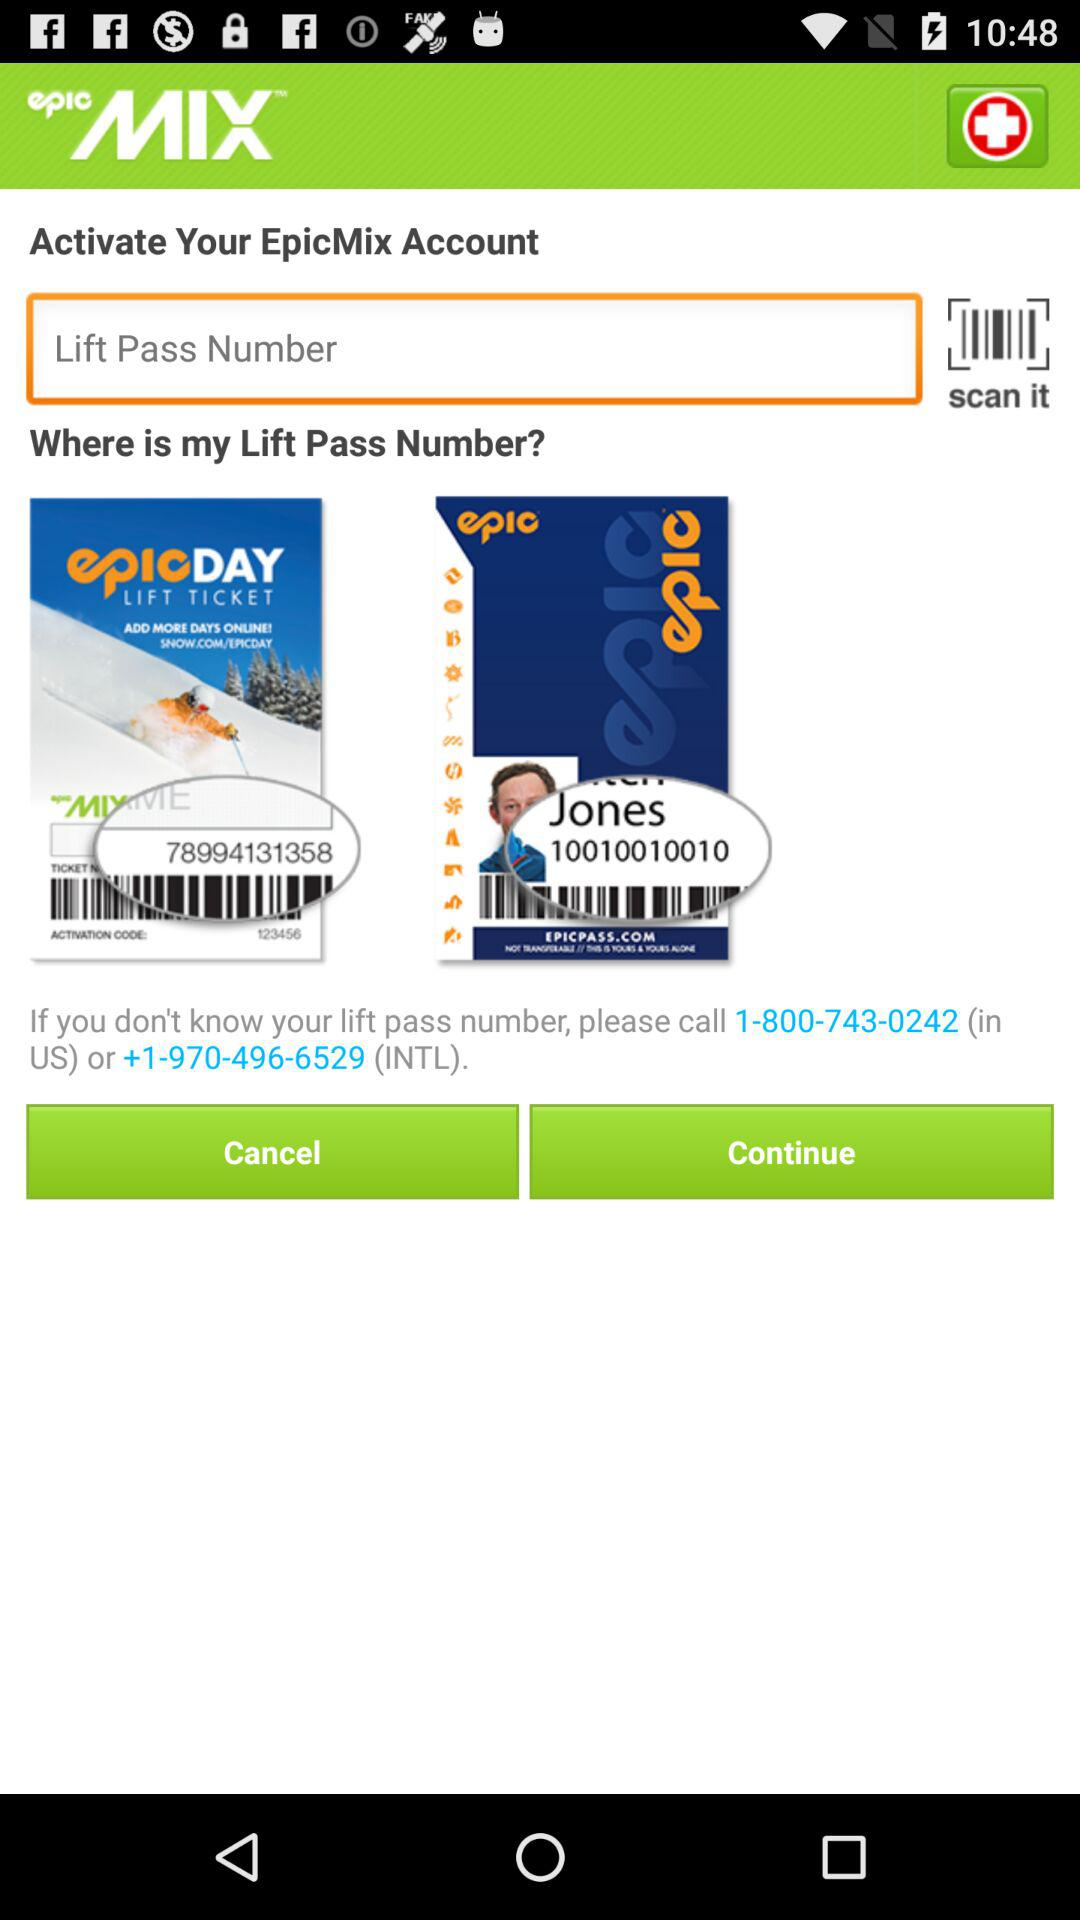How do we get a lift pass number? You can get a lift pass number by calling 1-800-743-0242 (in US) or +1-970-496-6529 (INTL). 